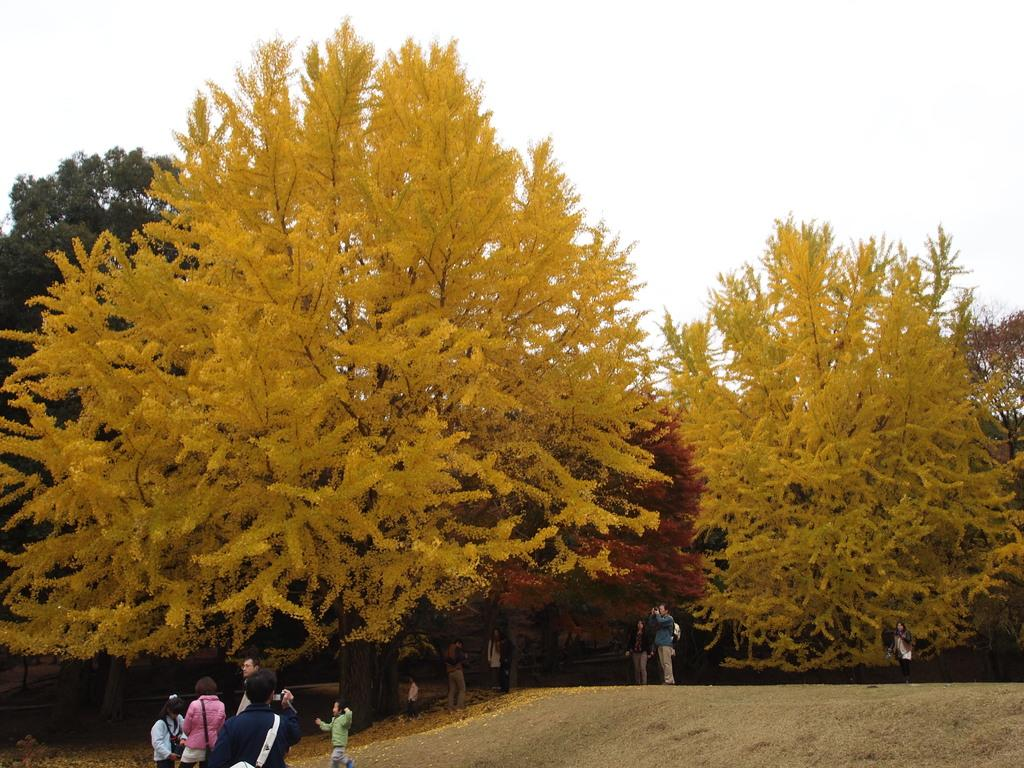How many people are in the image? There is a group of people in the image, but the exact number cannot be determined from the provided facts. What can be seen in the background of the image? There are trees in the image. Is there a river flowing through the group of people in the image? There is no mention of a river in the provided facts, so it cannot be determined if there is a river present in the image. What color is the shirt worn by the fly in the image? There is no fly present in the image, so it cannot be determined what color its shirt would be. 